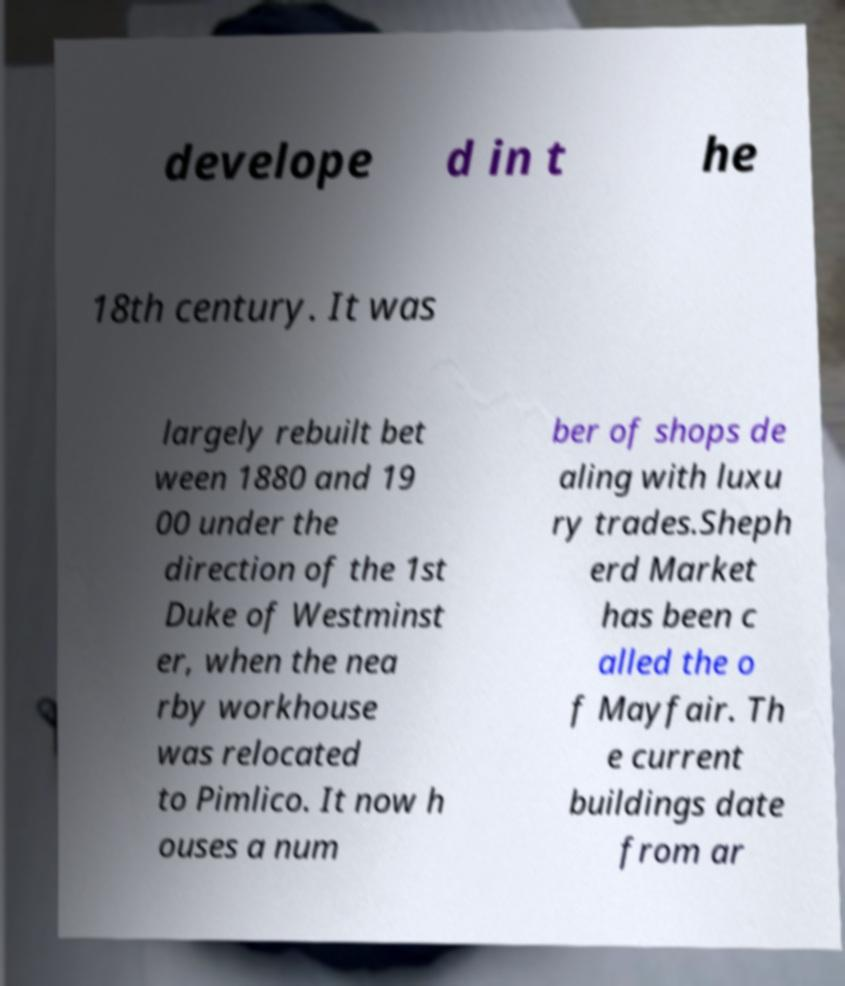Can you accurately transcribe the text from the provided image for me? develope d in t he 18th century. It was largely rebuilt bet ween 1880 and 19 00 under the direction of the 1st Duke of Westminst er, when the nea rby workhouse was relocated to Pimlico. It now h ouses a num ber of shops de aling with luxu ry trades.Sheph erd Market has been c alled the o f Mayfair. Th e current buildings date from ar 